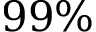Convert formula to latex. <formula><loc_0><loc_0><loc_500><loc_500>9 9 \%</formula> 